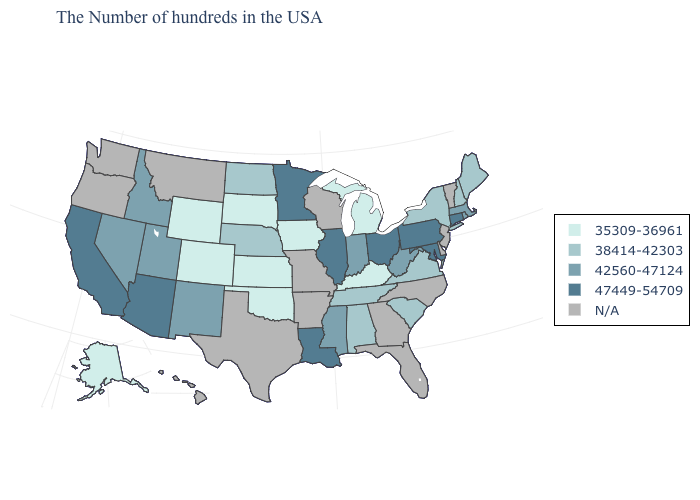Does Connecticut have the highest value in the Northeast?
Quick response, please. Yes. What is the lowest value in the USA?
Keep it brief. 35309-36961. Which states hav the highest value in the South?
Be succinct. Maryland, Louisiana. What is the lowest value in the South?
Quick response, please. 35309-36961. Name the states that have a value in the range 42560-47124?
Be succinct. Massachusetts, Rhode Island, West Virginia, Indiana, Mississippi, New Mexico, Utah, Idaho, Nevada. Name the states that have a value in the range N/A?
Answer briefly. Vermont, New Jersey, Delaware, North Carolina, Florida, Georgia, Wisconsin, Missouri, Arkansas, Texas, Montana, Washington, Oregon, Hawaii. Which states hav the highest value in the MidWest?
Concise answer only. Ohio, Illinois, Minnesota. What is the lowest value in states that border Georgia?
Short answer required. 38414-42303. What is the value of Hawaii?
Short answer required. N/A. What is the highest value in the West ?
Quick response, please. 47449-54709. Name the states that have a value in the range 47449-54709?
Keep it brief. Connecticut, Maryland, Pennsylvania, Ohio, Illinois, Louisiana, Minnesota, Arizona, California. What is the value of Georgia?
Answer briefly. N/A. Name the states that have a value in the range 35309-36961?
Short answer required. Michigan, Kentucky, Iowa, Kansas, Oklahoma, South Dakota, Wyoming, Colorado, Alaska. 